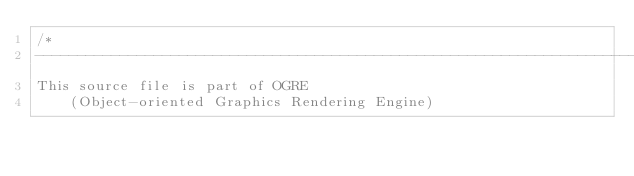Convert code to text. <code><loc_0><loc_0><loc_500><loc_500><_C++_>/*
-----------------------------------------------------------------------------
This source file is part of OGRE
    (Object-oriented Graphics Rendering Engine)</code> 